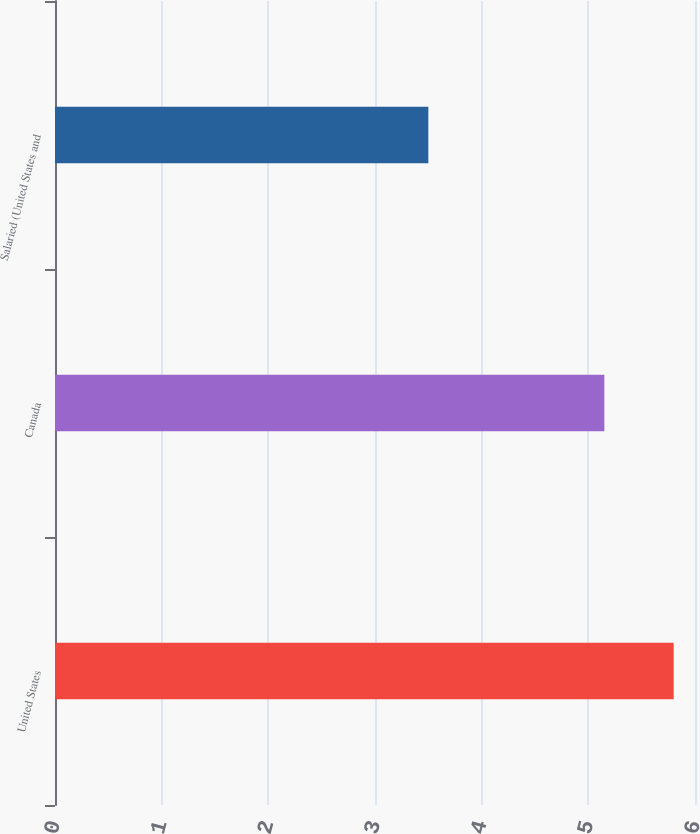Convert chart to OTSL. <chart><loc_0><loc_0><loc_500><loc_500><bar_chart><fcel>United States<fcel>Canada<fcel>Salaried (United States and<nl><fcel>5.8<fcel>5.15<fcel>3.5<nl></chart> 